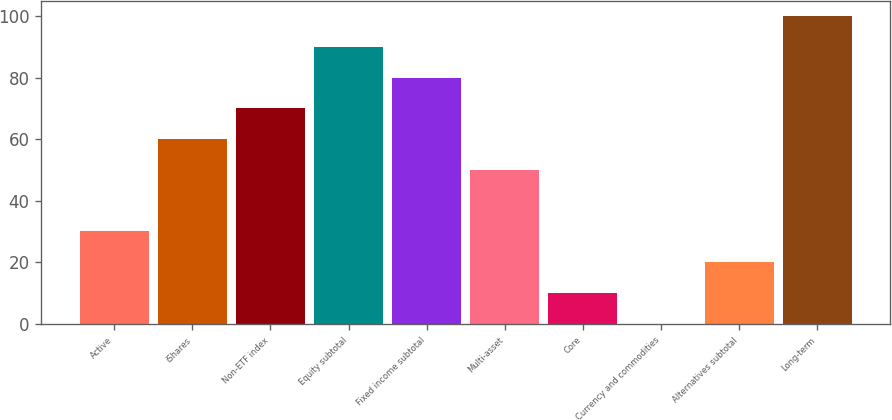Convert chart. <chart><loc_0><loc_0><loc_500><loc_500><bar_chart><fcel>Active<fcel>iShares<fcel>Non-ETF index<fcel>Equity subtotal<fcel>Fixed income subtotal<fcel>Multi-asset<fcel>Core<fcel>Currency and commodities<fcel>Alternatives subtotal<fcel>Long-term<nl><fcel>30.09<fcel>60.06<fcel>70.05<fcel>90.03<fcel>80.04<fcel>50.07<fcel>10.11<fcel>0.12<fcel>20.1<fcel>100.02<nl></chart> 